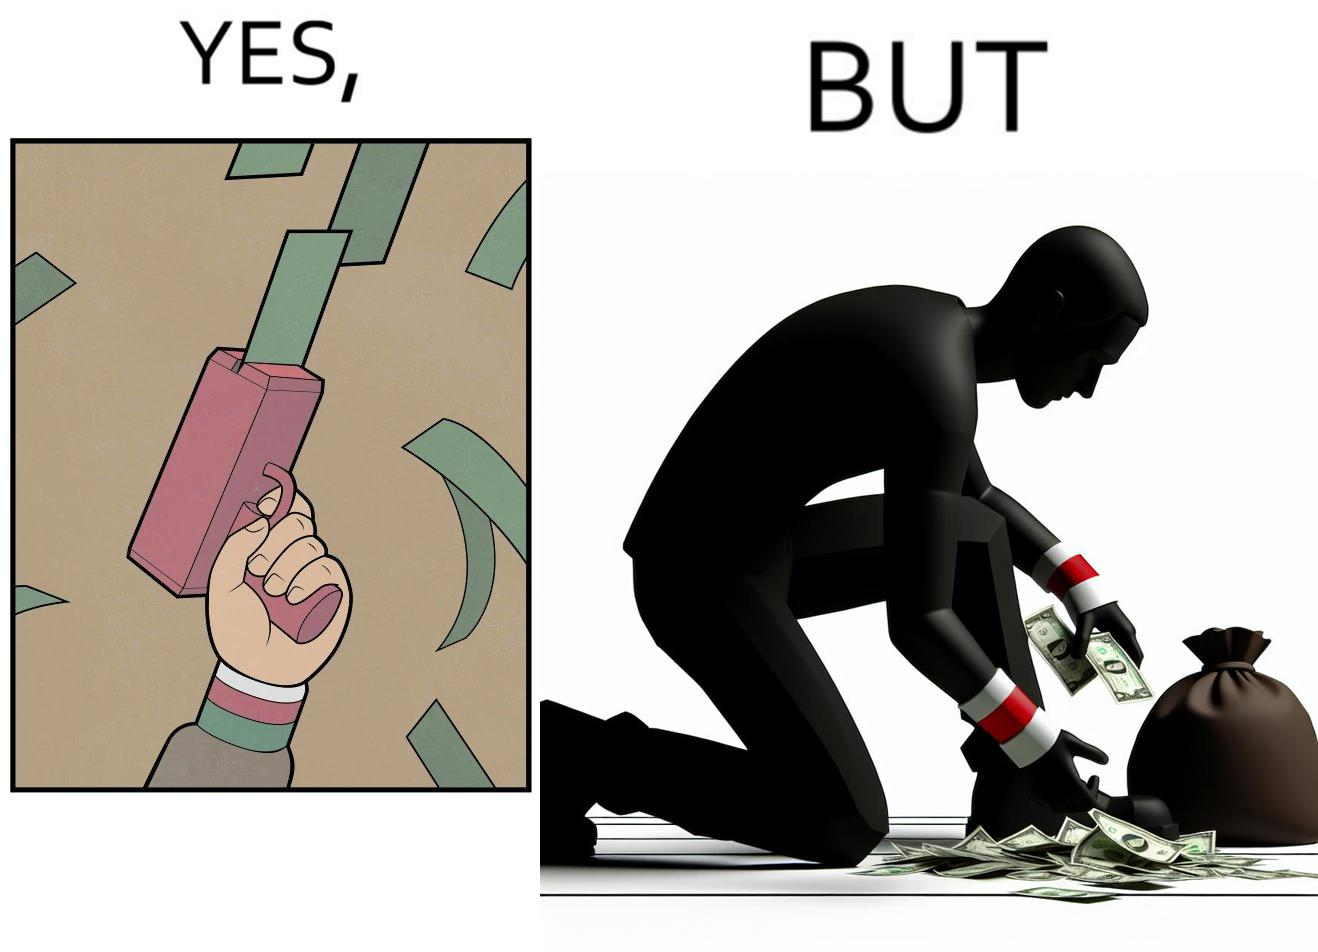What do you see in each half of this image? In the left part of the image: The image shows a hand holding a gun like object that is shooting out money bills in the air. The man's cuffs are green,red and white. In the right part of the image: The image showns a man crouching down to pick up fallen money bills on the ground. The man's cuffs are green, red and white. 